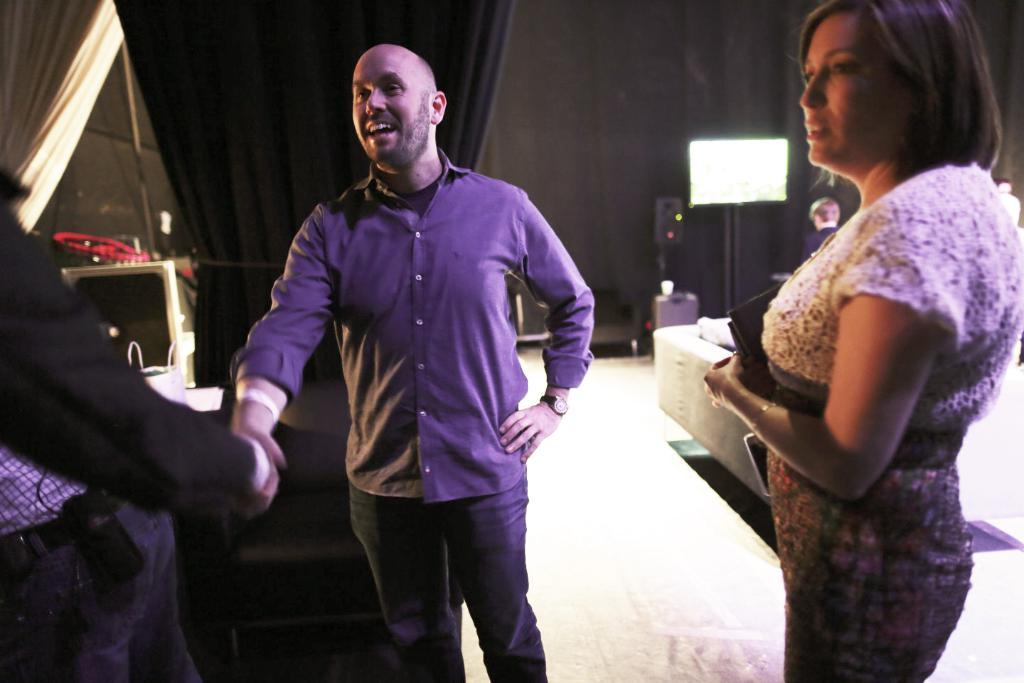How many people are in the image? There are people in the image, but the exact number is not specified. What is the surface beneath the people? There is a floor in the image. What type of furniture is present in the image? There is a couch in the image. What type of window treatment is visible in the image? There are curtains in the image. What type of screen is present in the image? There is a screen in the image, but its purpose or function is not specified. What type of wall is visible in the image? There is a wall in the image. What other unspecified objects are present in the image? There are unspecified objects in the image, but their nature or purpose is not described. What type of garden can be seen through the window in the image? There is no garden visible through the window in the image. What type of coal is being used to heat the room in the image? There is no mention of coal or any heating source in the image. How many mice are hiding behind the couch in the image? There is no mention of mice or any animals in the image. 